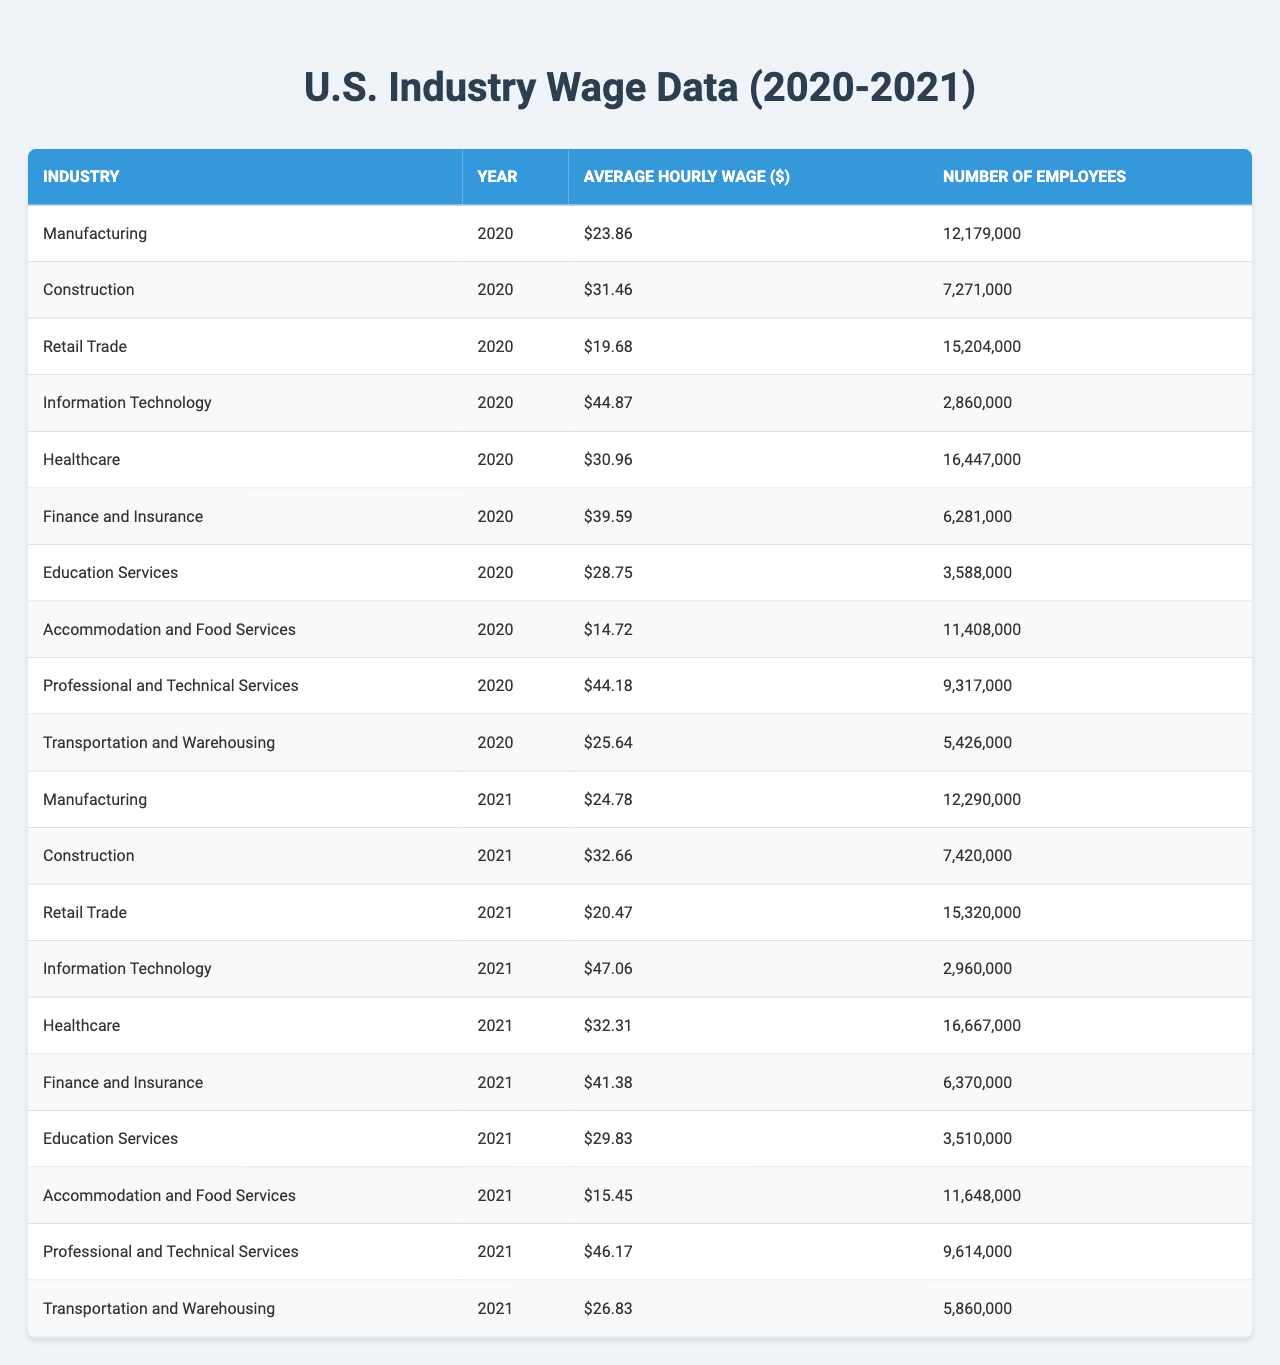What is the average hourly wage for the Healthcare industry in 2021? The table shows that the average hourly wage for the Healthcare industry in 2021 is $32.31.
Answer: $32.31 Which industry had the highest average hourly wage in 2020? By examining the table, the Information Technology industry had the highest average hourly wage in 2020 at $44.87.
Answer: Information Technology How much did the average hourly wage increase for Manufacturing from 2020 to 2021? The average hourly wage for Manufacturing in 2020 was $23.86 and in 2021 it increased to $24.78. Thus, the increase is $24.78 - $23.86 = $0.92.
Answer: $0.92 What is the total number of employees across all industries in 2021? To find out, I will sum the number of employees from each industry in 2021: 7,429,000 + 15,320,000 + 2,960,000 + 16,667,000 + 6,370,000 + 3,510,000 + 11,648,000 + 9,614,000 + 5,860,000 = 73,048,000.
Answer: 73,048,000 Did the average hourly wage for the Transportation and Warehousing industry decrease from 2020 to 2021? In 2020, the wage was $25.64, and in 2021 it increased to $26.83. Therefore, the wage did not decrease; it increased.
Answer: No What is the average hourly wage for Professional and Technical Services across both years? In 2020, the average hourly wage was $44.18, and in 2021 it was $46.17. To find the average across both years: ($44.18 + $46.17) / 2 = $45.18.
Answer: $45.18 Which two industries show the largest wage gap from 2020 to 2021? For each industry, I will calculate the wage difference: Manufacturing ($0.92), Construction ($1.20), Retail Trade ($0.79), Information Technology ($2.19), Healthcare ($1.35), Finance and Insurance ($1.79), Education Services ($1.08), Accommodation and Food Services ($0.73), and Professional and Technical Services ($2.00). The largest gap is between Information Technology ($2.19) and Professional and Technical Services ($2.00).
Answer: Information Technology and Professional and Technical Services What was the average hourly wage for the Retail Trade industry in 2020 and how does it compare to the average wage for the same industry in 2021? The average hourly wage for Retail Trade in 2020 was $19.68 and in 2021 it rose to $20.47. The increase shows that the wage went up by $20.47 - $19.68 = $0.79.
Answer: $19.68 in 2020; $20.47 in 2021; increase of $0.79 Which industry had the lowest average hourly wage in 2020? By reviewing the table, Accommodation and Food Services had the lowest average hourly wage in 2020 at $14.72.
Answer: Accommodation and Food Services Is the Finance and Insurance industry among the top three highest wages in 2021? The average hourly wages for the top three industries in 2021 are Information Technology ($47.06), Professional and Technical Services ($46.17), and Finance and Insurance ($41.38). Therefore, Finance and Insurance is in the top three.
Answer: Yes 